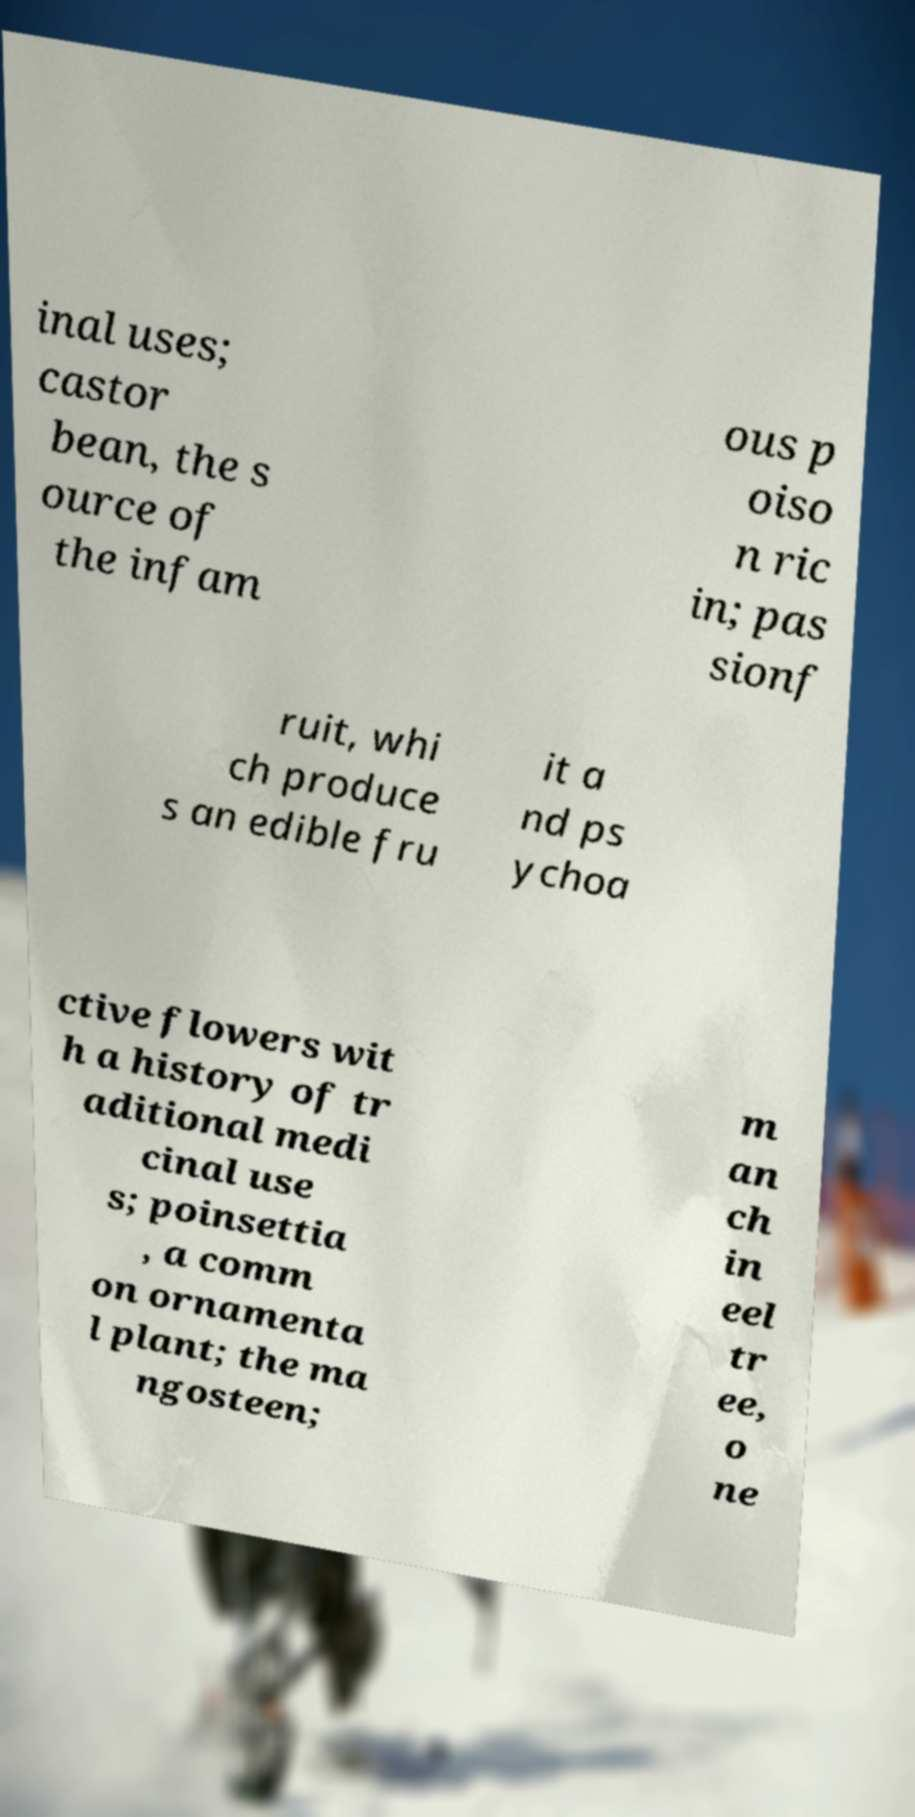Can you accurately transcribe the text from the provided image for me? inal uses; castor bean, the s ource of the infam ous p oiso n ric in; pas sionf ruit, whi ch produce s an edible fru it a nd ps ychoa ctive flowers wit h a history of tr aditional medi cinal use s; poinsettia , a comm on ornamenta l plant; the ma ngosteen; m an ch in eel tr ee, o ne 